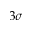Convert formula to latex. <formula><loc_0><loc_0><loc_500><loc_500>3 \sigma</formula> 